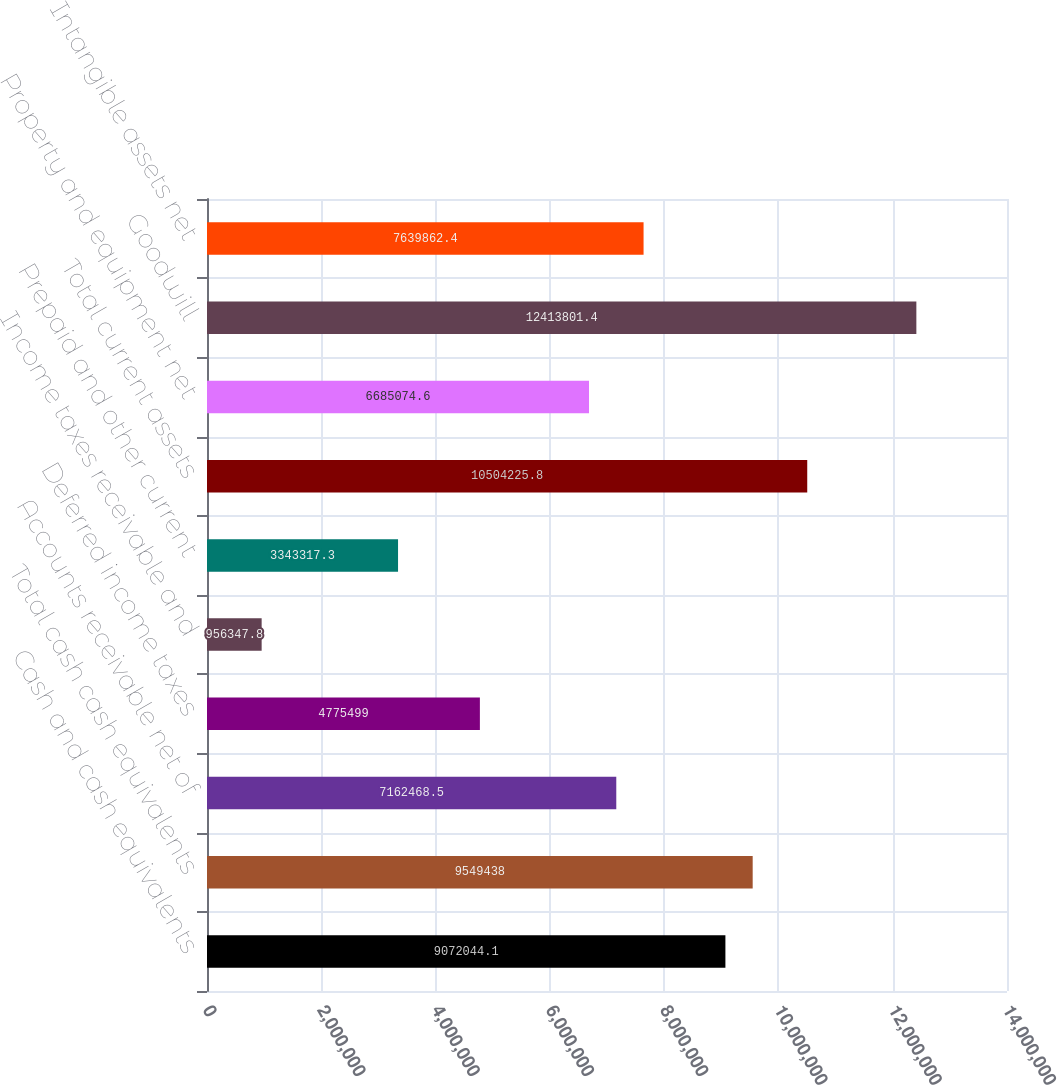Convert chart. <chart><loc_0><loc_0><loc_500><loc_500><bar_chart><fcel>Cash and cash equivalents<fcel>Total cash cash equivalents<fcel>Accounts receivable net of<fcel>Deferred income taxes<fcel>Income taxes receivable and<fcel>Prepaid and other current<fcel>Total current assets<fcel>Property and equipment net<fcel>Goodwill<fcel>Intangible assets net<nl><fcel>9.07204e+06<fcel>9.54944e+06<fcel>7.16247e+06<fcel>4.7755e+06<fcel>956348<fcel>3.34332e+06<fcel>1.05042e+07<fcel>6.68507e+06<fcel>1.24138e+07<fcel>7.63986e+06<nl></chart> 